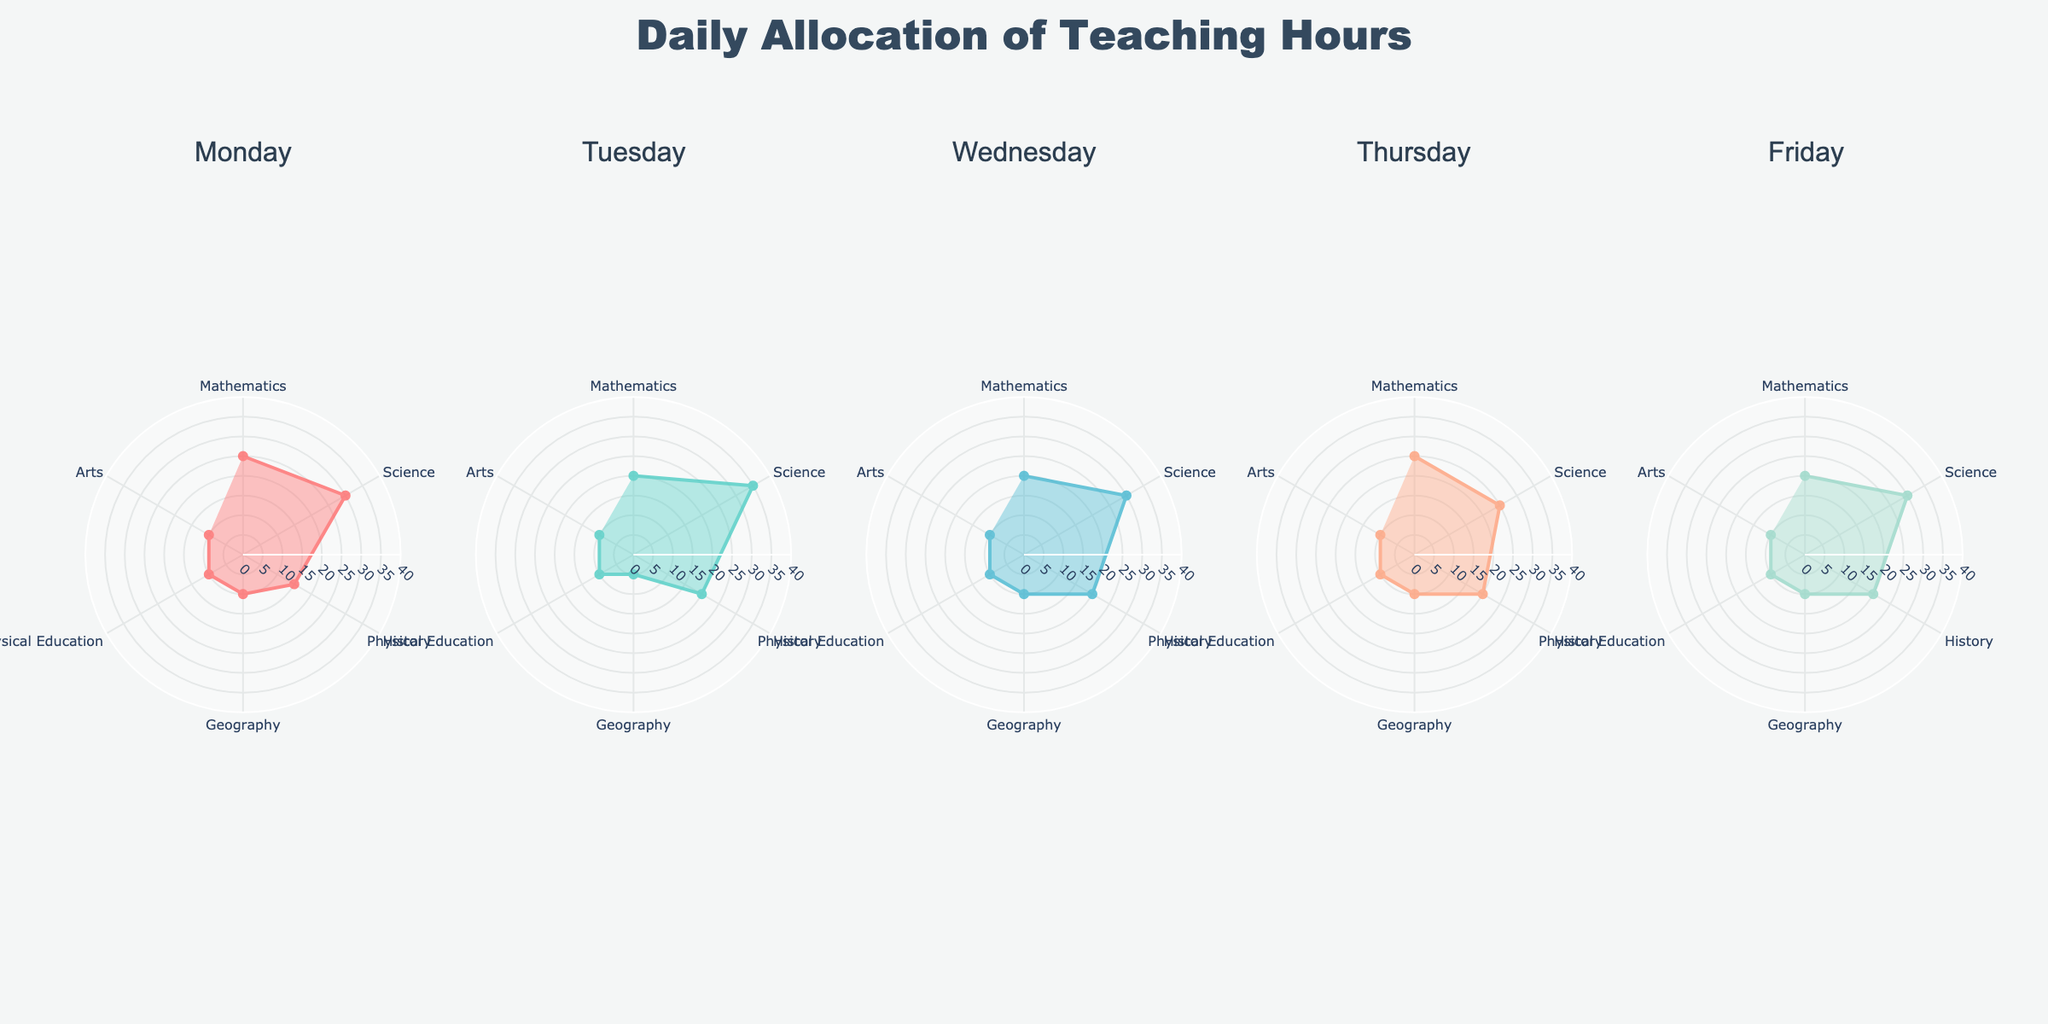What is the title of the figure? The title of the figure is usually placed at the top center of the figure. In this case, it reads "Daily Allocation of Teaching Hours".
Answer: Daily Allocation of Teaching Hours How many subjects are displayed in the figure? The figure shows a polar chart with categories or segments for subjects. By counting them, we find there are 6 subjects displayed: Mathematics, Science, History, Geography, Physical Education, and Arts.
Answer: 6 Which subject has the highest allocated teaching hours on Monday? By looking at Monday's subplot, the segment with the highest radial distance corresponds to Science, which has 30% of teaching hours.
Answer: Science What is the range of the radial axis in the polar charts? The radial axis range can be seen by checking the maximum value on the radial gridlines. In this figure, it ranges from 0 to 40 percent.
Answer: 0 to 40 percent How does the allocation for Mathematics change from Monday to Friday? To find this, observe the radial length in the subplots for Mathematics across all days. On Monday it's 25%, Tuesday 20%, Wednesday 20%, Thursday 25%, and Friday 20%.
Answer: It varies between 20% and 25% Which day has the most evenly distributed teaching hours across all subjects? Comparing the radial distances in each subplot, Thursday shows the most even distribution as most subjects are close to each other in their percentage allocation.
Answer: Thursday What is the total allocation of teaching hours for Physical Education over the week? Sum the percentages for Physical Education for each day: 10% (Monday) + 10% (Tuesday) + 10% (Wednesday) + 10% (Thursday) + 10% (Friday) = 50%.
Answer: 50% Which subject consistently has the lowest allocation of teaching hours throughout the week? Identify the subject with the smallest radial distance in each subplot. Geography and Physical Education, both consistently at 10%, share this characteristic.
Answer: Geography and Physical Education Is there a day where Science does not have the highest allocation of teaching hours? Check each subplot for the longest segment in terms of radial distance. On Tuesday, Science has 35% while Mathematics has 20%, so Science still has the highest allocation. Thus, Science is the highest every day.
Answer: No Does the allocation of any subject peak mid-week? Look for any spikes in mid-week data, specifically Wednesday. The highest allocation is shared by Science (30%), which matches the general trend but does not peak above other days.
Answer: No 